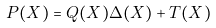<formula> <loc_0><loc_0><loc_500><loc_500>P ( X ) = Q ( X ) \Delta ( X ) + T ( X )</formula> 